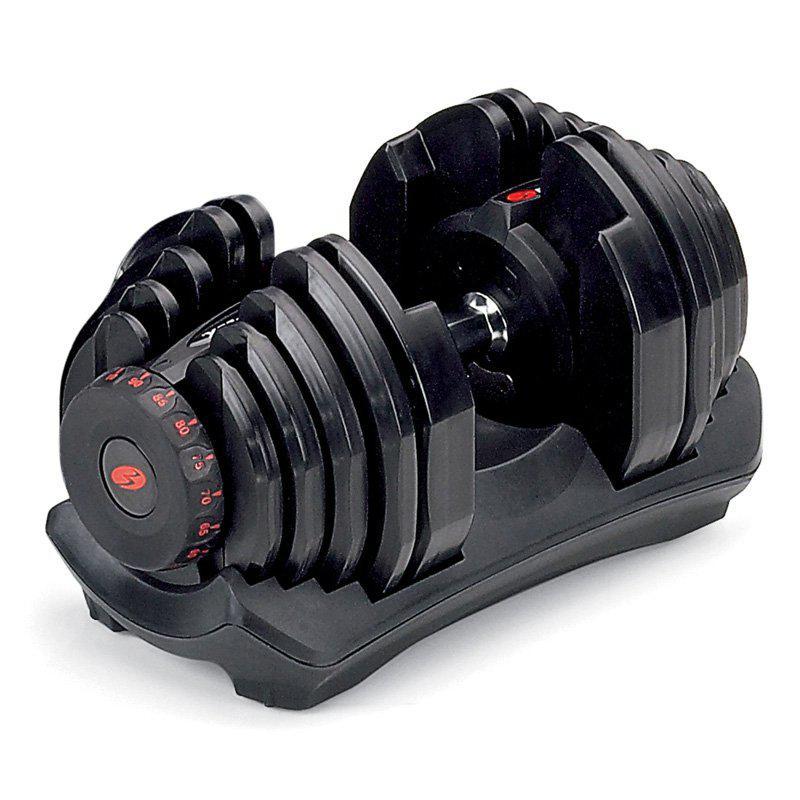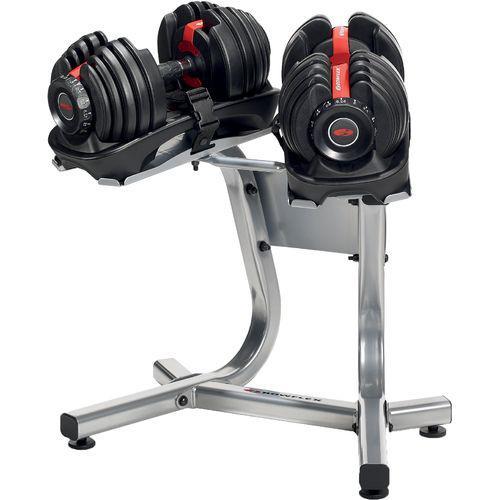The first image is the image on the left, the second image is the image on the right. Assess this claim about the two images: "The left and right image contains a total of three dumbbells.". Correct or not? Answer yes or no. Yes. The first image is the image on the left, the second image is the image on the right. Examine the images to the left and right. Is the description "The combined images include three dumbbell bars with weights on each end." accurate? Answer yes or no. Yes. 